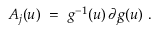Convert formula to latex. <formula><loc_0><loc_0><loc_500><loc_500>A _ { j } ( u ) = g ^ { - 1 } ( u ) \, \partial _ { j } \, g ( u ) .</formula> 